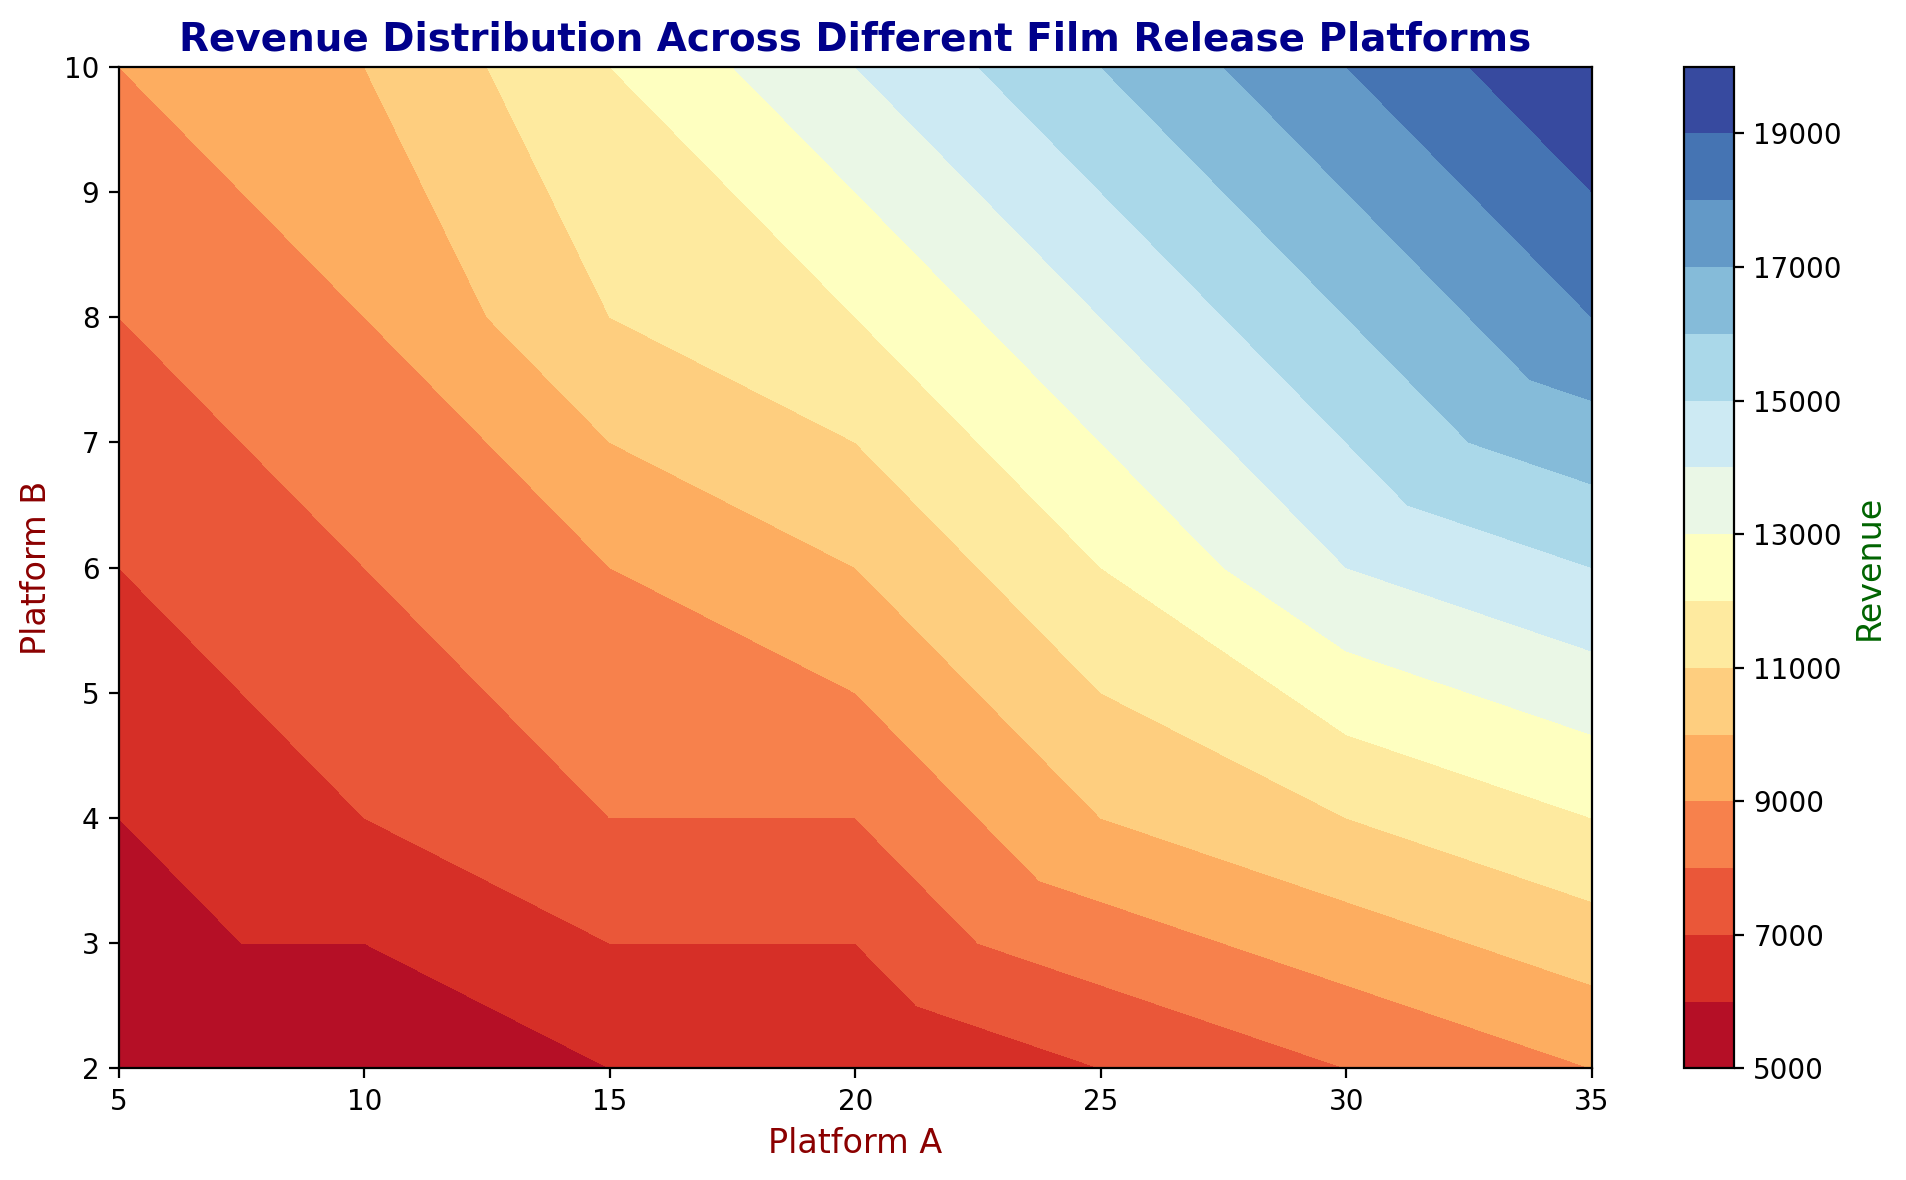What is the general trend of revenue as Platform A increases when Platform B is fixed at 2? To answer this, look at the contour levels for different values of Platform B fixed at 2. Follow the progression of values in revenue as Platform A goes from 5 to 35. The revenue generally increases as Platform A goes up from 5 to 35 while Platform B is held constant at 2.
Answer: Revenue generally increases Which combination of Platform A and Platform B yields the highest revenue visible in the plot? Find the combination of values for Platform A and Platform B where the highest contour level is observed. By examining the contour plot, we can determine that the combination occurs where Platform A is 35 and Platform B is 10, which gives the maximum revenue of 20000.
Answer: Platform A: 35, Platform B: 10 How does revenue change visually when comparing Platform B values at 4 and 8 for a Platform A value of 20? Identify where the contours cross the lines for Platform B at 4 and 8 when Platform A is 20. The color gradient indicates an increase in revenue from around 8000 at Platform B of 4 to around 12000 at Platform B of 8. This shows a significant increase in revenue.
Answer: Increases from 8000 to 12000 Estimate the revenue generated when Platform A is set to 15 and Platform B is set to 6. Find the point where Platform A is 15 and Platform B is 6 on the contour plot. Identify the contour color or level at this point. The corresponding contour level indicates a revenue of approximately 9000.
Answer: 9000 Is the revenue more sensitive to changes in Platform A or Platform B? Observe how steeply the contour levels change with varying Platform A while keeping Platform B constant, and vice versa. Revenue shows a steeper gradient when Platform A varies, indicating more sensitivity to Platform A compared to Platform B. For instance, for Platform B fixed at 8, revenue increases more rapidly with changing Platform A than for Platform A fixed at 15 and changing Platform B.
Answer: Platform A How much higher is the revenue for Platform A at 35 compared to Platform A at 20 when Platform B is fixed at 4? Locate the revenue levels for Platform A at 35 and 20 along the line where Platform B is fixed at 4. The revenue at Platform A of 35 is around 12000, while at 20 it is around 8000. The difference is calculated as 12000 - 8000.
Answer: 4000 At which Platform A value does the revenue first reach 8000 when Platform B is kept constant at 2? Follow the contour lines for Platform B at 2 and find the value of Platform A where the revenue first hits 8000. The contours show that for Platform B fixed at 2, revenue reaches 8000 around Platform A of 30.
Answer: 30 